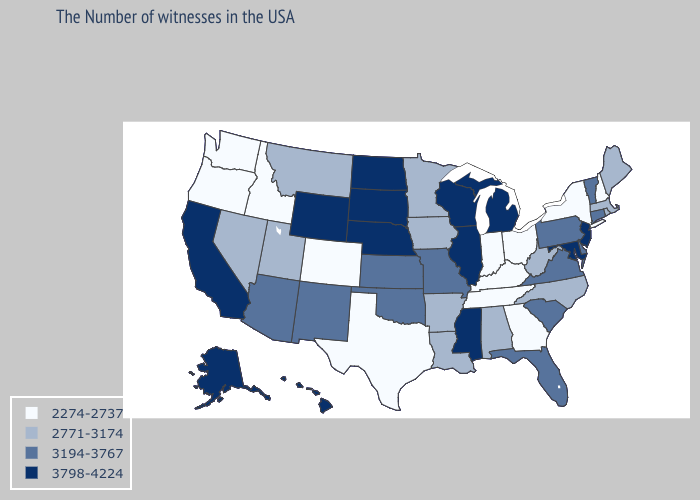What is the value of Washington?
Keep it brief. 2274-2737. Name the states that have a value in the range 3798-4224?
Keep it brief. New Jersey, Maryland, Michigan, Wisconsin, Illinois, Mississippi, Nebraska, South Dakota, North Dakota, Wyoming, California, Alaska, Hawaii. Name the states that have a value in the range 2274-2737?
Write a very short answer. New Hampshire, New York, Ohio, Georgia, Kentucky, Indiana, Tennessee, Texas, Colorado, Idaho, Washington, Oregon. Does the first symbol in the legend represent the smallest category?
Short answer required. Yes. Name the states that have a value in the range 2771-3174?
Quick response, please. Maine, Massachusetts, Rhode Island, North Carolina, West Virginia, Alabama, Louisiana, Arkansas, Minnesota, Iowa, Utah, Montana, Nevada. Name the states that have a value in the range 3194-3767?
Give a very brief answer. Vermont, Connecticut, Delaware, Pennsylvania, Virginia, South Carolina, Florida, Missouri, Kansas, Oklahoma, New Mexico, Arizona. Name the states that have a value in the range 2771-3174?
Answer briefly. Maine, Massachusetts, Rhode Island, North Carolina, West Virginia, Alabama, Louisiana, Arkansas, Minnesota, Iowa, Utah, Montana, Nevada. Among the states that border Massachusetts , does Vermont have the highest value?
Short answer required. Yes. What is the value of Kansas?
Short answer required. 3194-3767. What is the value of Nevada?
Be succinct. 2771-3174. Which states have the lowest value in the USA?
Keep it brief. New Hampshire, New York, Ohio, Georgia, Kentucky, Indiana, Tennessee, Texas, Colorado, Idaho, Washington, Oregon. Does Wyoming have the highest value in the USA?
Be succinct. Yes. Does the first symbol in the legend represent the smallest category?
Concise answer only. Yes. What is the value of South Carolina?
Keep it brief. 3194-3767. 